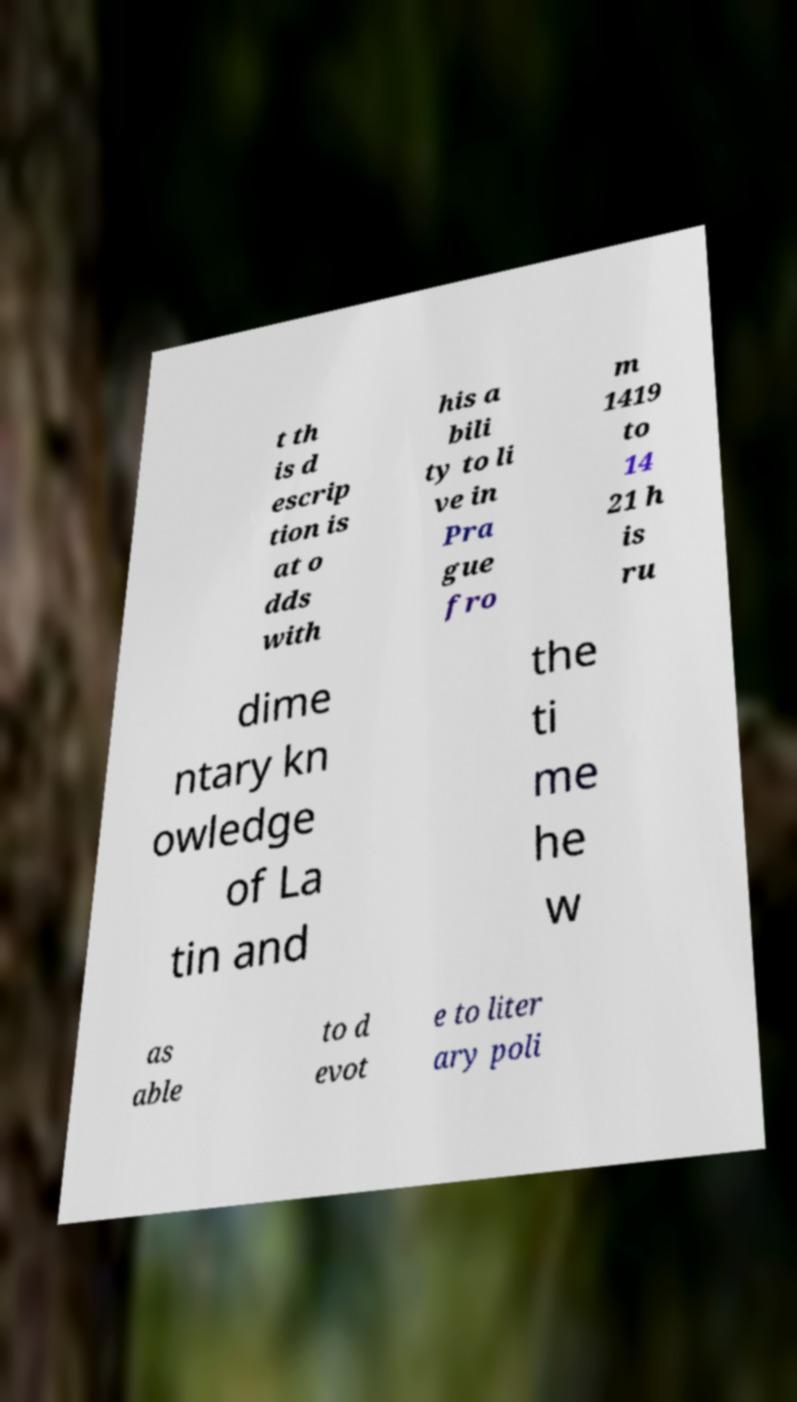Please identify and transcribe the text found in this image. t th is d escrip tion is at o dds with his a bili ty to li ve in Pra gue fro m 1419 to 14 21 h is ru dime ntary kn owledge of La tin and the ti me he w as able to d evot e to liter ary poli 